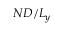<formula> <loc_0><loc_0><loc_500><loc_500>N D / L _ { y }</formula> 